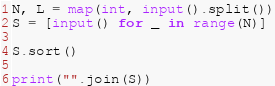Convert code to text. <code><loc_0><loc_0><loc_500><loc_500><_Python_>N, L = map(int, input().split())
S = [input() for _ in range(N)]

S.sort()

print("".join(S))</code> 